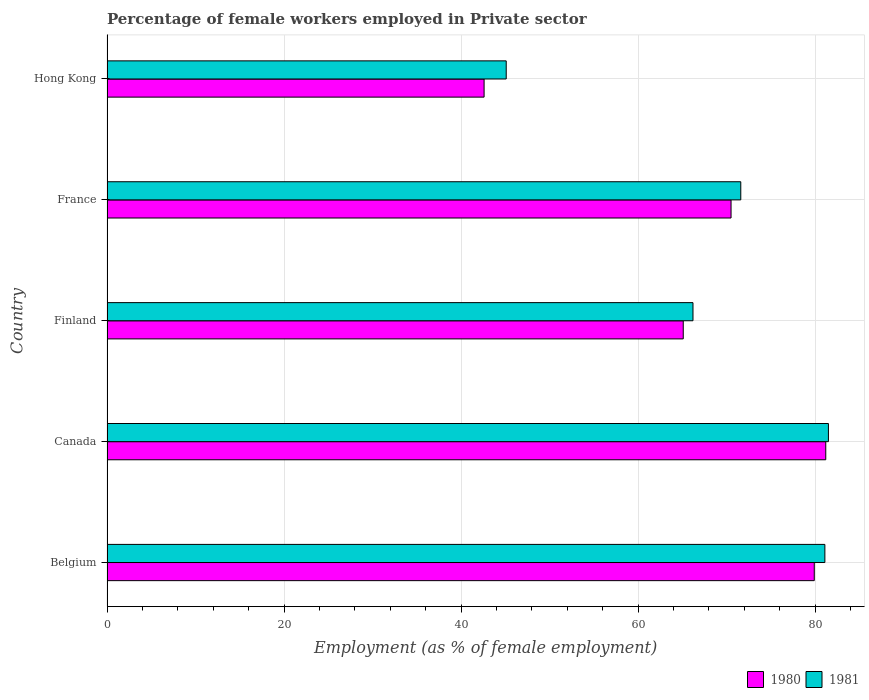How many different coloured bars are there?
Your response must be concise. 2. Are the number of bars on each tick of the Y-axis equal?
Your answer should be very brief. Yes. How many bars are there on the 4th tick from the top?
Make the answer very short. 2. What is the label of the 2nd group of bars from the top?
Your response must be concise. France. What is the percentage of females employed in Private sector in 1980 in Canada?
Make the answer very short. 81.2. Across all countries, what is the maximum percentage of females employed in Private sector in 1980?
Make the answer very short. 81.2. Across all countries, what is the minimum percentage of females employed in Private sector in 1980?
Offer a terse response. 42.6. In which country was the percentage of females employed in Private sector in 1980 maximum?
Keep it short and to the point. Canada. In which country was the percentage of females employed in Private sector in 1980 minimum?
Provide a short and direct response. Hong Kong. What is the total percentage of females employed in Private sector in 1981 in the graph?
Ensure brevity in your answer.  345.5. What is the difference between the percentage of females employed in Private sector in 1980 in Finland and that in Hong Kong?
Provide a short and direct response. 22.5. What is the difference between the percentage of females employed in Private sector in 1981 in Hong Kong and the percentage of females employed in Private sector in 1980 in Canada?
Provide a short and direct response. -36.1. What is the average percentage of females employed in Private sector in 1981 per country?
Offer a very short reply. 69.1. What is the difference between the percentage of females employed in Private sector in 1980 and percentage of females employed in Private sector in 1981 in Finland?
Make the answer very short. -1.1. In how many countries, is the percentage of females employed in Private sector in 1980 greater than 68 %?
Give a very brief answer. 3. What is the ratio of the percentage of females employed in Private sector in 1980 in Finland to that in France?
Offer a terse response. 0.92. Is the difference between the percentage of females employed in Private sector in 1980 in Canada and Finland greater than the difference between the percentage of females employed in Private sector in 1981 in Canada and Finland?
Your answer should be very brief. Yes. What is the difference between the highest and the second highest percentage of females employed in Private sector in 1981?
Your response must be concise. 0.4. What is the difference between the highest and the lowest percentage of females employed in Private sector in 1980?
Provide a short and direct response. 38.6. Is the sum of the percentage of females employed in Private sector in 1980 in Belgium and Hong Kong greater than the maximum percentage of females employed in Private sector in 1981 across all countries?
Give a very brief answer. Yes. What does the 2nd bar from the top in France represents?
Your answer should be very brief. 1980. What does the 1st bar from the bottom in Canada represents?
Provide a short and direct response. 1980. How many bars are there?
Give a very brief answer. 10. Are all the bars in the graph horizontal?
Your response must be concise. Yes. How many countries are there in the graph?
Provide a short and direct response. 5. What is the difference between two consecutive major ticks on the X-axis?
Provide a short and direct response. 20. Does the graph contain any zero values?
Keep it short and to the point. No. Where does the legend appear in the graph?
Your answer should be very brief. Bottom right. How many legend labels are there?
Ensure brevity in your answer.  2. How are the legend labels stacked?
Provide a succinct answer. Horizontal. What is the title of the graph?
Your answer should be very brief. Percentage of female workers employed in Private sector. What is the label or title of the X-axis?
Offer a very short reply. Employment (as % of female employment). What is the label or title of the Y-axis?
Your answer should be compact. Country. What is the Employment (as % of female employment) of 1980 in Belgium?
Keep it short and to the point. 79.9. What is the Employment (as % of female employment) in 1981 in Belgium?
Offer a very short reply. 81.1. What is the Employment (as % of female employment) in 1980 in Canada?
Ensure brevity in your answer.  81.2. What is the Employment (as % of female employment) in 1981 in Canada?
Provide a succinct answer. 81.5. What is the Employment (as % of female employment) of 1980 in Finland?
Your response must be concise. 65.1. What is the Employment (as % of female employment) of 1981 in Finland?
Your response must be concise. 66.2. What is the Employment (as % of female employment) of 1980 in France?
Your response must be concise. 70.5. What is the Employment (as % of female employment) in 1981 in France?
Your answer should be compact. 71.6. What is the Employment (as % of female employment) of 1980 in Hong Kong?
Your response must be concise. 42.6. What is the Employment (as % of female employment) in 1981 in Hong Kong?
Provide a succinct answer. 45.1. Across all countries, what is the maximum Employment (as % of female employment) in 1980?
Your answer should be compact. 81.2. Across all countries, what is the maximum Employment (as % of female employment) of 1981?
Your response must be concise. 81.5. Across all countries, what is the minimum Employment (as % of female employment) of 1980?
Offer a very short reply. 42.6. Across all countries, what is the minimum Employment (as % of female employment) of 1981?
Offer a terse response. 45.1. What is the total Employment (as % of female employment) in 1980 in the graph?
Your answer should be compact. 339.3. What is the total Employment (as % of female employment) of 1981 in the graph?
Your response must be concise. 345.5. What is the difference between the Employment (as % of female employment) of 1981 in Belgium and that in Canada?
Make the answer very short. -0.4. What is the difference between the Employment (as % of female employment) of 1981 in Belgium and that in Finland?
Your answer should be very brief. 14.9. What is the difference between the Employment (as % of female employment) of 1980 in Belgium and that in France?
Offer a very short reply. 9.4. What is the difference between the Employment (as % of female employment) of 1981 in Belgium and that in France?
Your response must be concise. 9.5. What is the difference between the Employment (as % of female employment) of 1980 in Belgium and that in Hong Kong?
Provide a short and direct response. 37.3. What is the difference between the Employment (as % of female employment) of 1980 in Canada and that in Finland?
Give a very brief answer. 16.1. What is the difference between the Employment (as % of female employment) in 1980 in Canada and that in France?
Offer a very short reply. 10.7. What is the difference between the Employment (as % of female employment) of 1980 in Canada and that in Hong Kong?
Ensure brevity in your answer.  38.6. What is the difference between the Employment (as % of female employment) in 1981 in Canada and that in Hong Kong?
Offer a very short reply. 36.4. What is the difference between the Employment (as % of female employment) of 1980 in Finland and that in Hong Kong?
Offer a very short reply. 22.5. What is the difference between the Employment (as % of female employment) in 1981 in Finland and that in Hong Kong?
Your answer should be compact. 21.1. What is the difference between the Employment (as % of female employment) of 1980 in France and that in Hong Kong?
Your answer should be compact. 27.9. What is the difference between the Employment (as % of female employment) of 1980 in Belgium and the Employment (as % of female employment) of 1981 in Canada?
Offer a very short reply. -1.6. What is the difference between the Employment (as % of female employment) in 1980 in Belgium and the Employment (as % of female employment) in 1981 in Finland?
Your answer should be compact. 13.7. What is the difference between the Employment (as % of female employment) of 1980 in Belgium and the Employment (as % of female employment) of 1981 in Hong Kong?
Provide a succinct answer. 34.8. What is the difference between the Employment (as % of female employment) in 1980 in Canada and the Employment (as % of female employment) in 1981 in Hong Kong?
Provide a succinct answer. 36.1. What is the difference between the Employment (as % of female employment) in 1980 in France and the Employment (as % of female employment) in 1981 in Hong Kong?
Give a very brief answer. 25.4. What is the average Employment (as % of female employment) in 1980 per country?
Ensure brevity in your answer.  67.86. What is the average Employment (as % of female employment) in 1981 per country?
Keep it short and to the point. 69.1. What is the difference between the Employment (as % of female employment) of 1980 and Employment (as % of female employment) of 1981 in Belgium?
Your answer should be very brief. -1.2. What is the difference between the Employment (as % of female employment) of 1980 and Employment (as % of female employment) of 1981 in Finland?
Offer a terse response. -1.1. What is the difference between the Employment (as % of female employment) in 1980 and Employment (as % of female employment) in 1981 in France?
Make the answer very short. -1.1. What is the ratio of the Employment (as % of female employment) of 1980 in Belgium to that in Canada?
Provide a short and direct response. 0.98. What is the ratio of the Employment (as % of female employment) of 1980 in Belgium to that in Finland?
Give a very brief answer. 1.23. What is the ratio of the Employment (as % of female employment) in 1981 in Belgium to that in Finland?
Give a very brief answer. 1.23. What is the ratio of the Employment (as % of female employment) of 1980 in Belgium to that in France?
Keep it short and to the point. 1.13. What is the ratio of the Employment (as % of female employment) of 1981 in Belgium to that in France?
Offer a very short reply. 1.13. What is the ratio of the Employment (as % of female employment) of 1980 in Belgium to that in Hong Kong?
Provide a succinct answer. 1.88. What is the ratio of the Employment (as % of female employment) of 1981 in Belgium to that in Hong Kong?
Your answer should be compact. 1.8. What is the ratio of the Employment (as % of female employment) in 1980 in Canada to that in Finland?
Offer a very short reply. 1.25. What is the ratio of the Employment (as % of female employment) in 1981 in Canada to that in Finland?
Make the answer very short. 1.23. What is the ratio of the Employment (as % of female employment) in 1980 in Canada to that in France?
Offer a very short reply. 1.15. What is the ratio of the Employment (as % of female employment) in 1981 in Canada to that in France?
Your answer should be compact. 1.14. What is the ratio of the Employment (as % of female employment) in 1980 in Canada to that in Hong Kong?
Give a very brief answer. 1.91. What is the ratio of the Employment (as % of female employment) of 1981 in Canada to that in Hong Kong?
Your answer should be very brief. 1.81. What is the ratio of the Employment (as % of female employment) of 1980 in Finland to that in France?
Give a very brief answer. 0.92. What is the ratio of the Employment (as % of female employment) of 1981 in Finland to that in France?
Keep it short and to the point. 0.92. What is the ratio of the Employment (as % of female employment) of 1980 in Finland to that in Hong Kong?
Provide a succinct answer. 1.53. What is the ratio of the Employment (as % of female employment) in 1981 in Finland to that in Hong Kong?
Offer a terse response. 1.47. What is the ratio of the Employment (as % of female employment) of 1980 in France to that in Hong Kong?
Your answer should be compact. 1.65. What is the ratio of the Employment (as % of female employment) in 1981 in France to that in Hong Kong?
Provide a short and direct response. 1.59. What is the difference between the highest and the second highest Employment (as % of female employment) of 1981?
Give a very brief answer. 0.4. What is the difference between the highest and the lowest Employment (as % of female employment) in 1980?
Offer a very short reply. 38.6. What is the difference between the highest and the lowest Employment (as % of female employment) in 1981?
Keep it short and to the point. 36.4. 